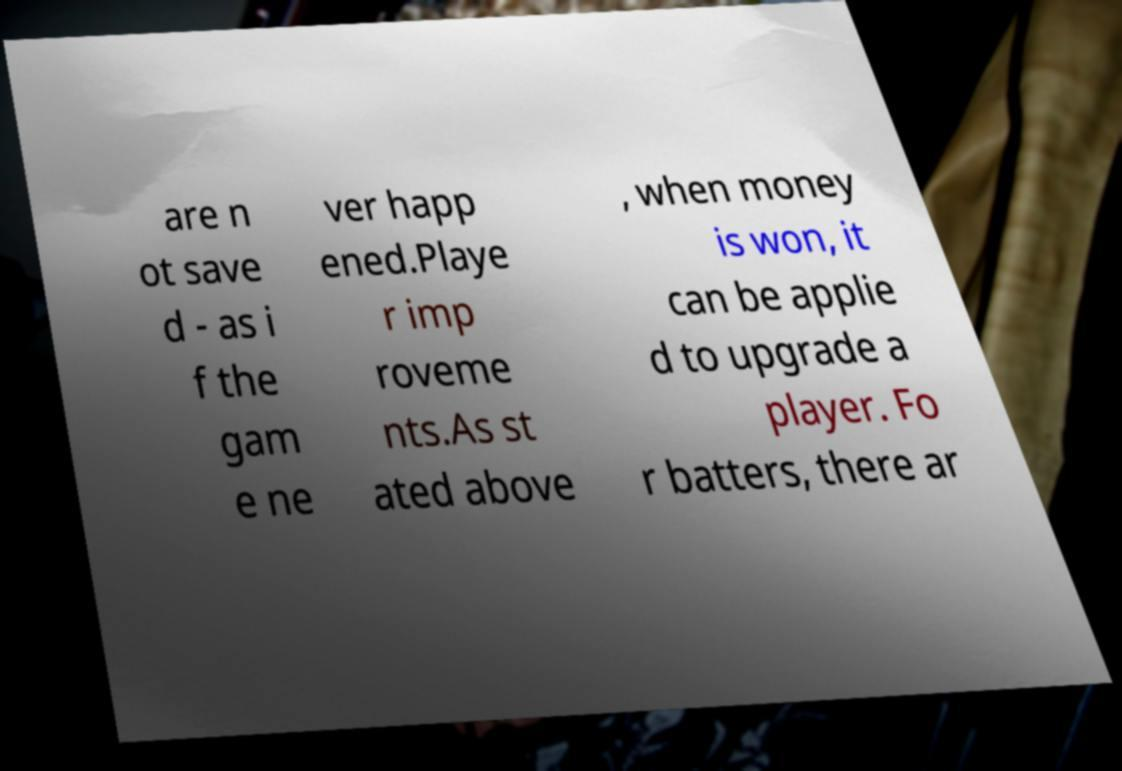What messages or text are displayed in this image? I need them in a readable, typed format. are n ot save d - as i f the gam e ne ver happ ened.Playe r imp roveme nts.As st ated above , when money is won, it can be applie d to upgrade a player. Fo r batters, there ar 